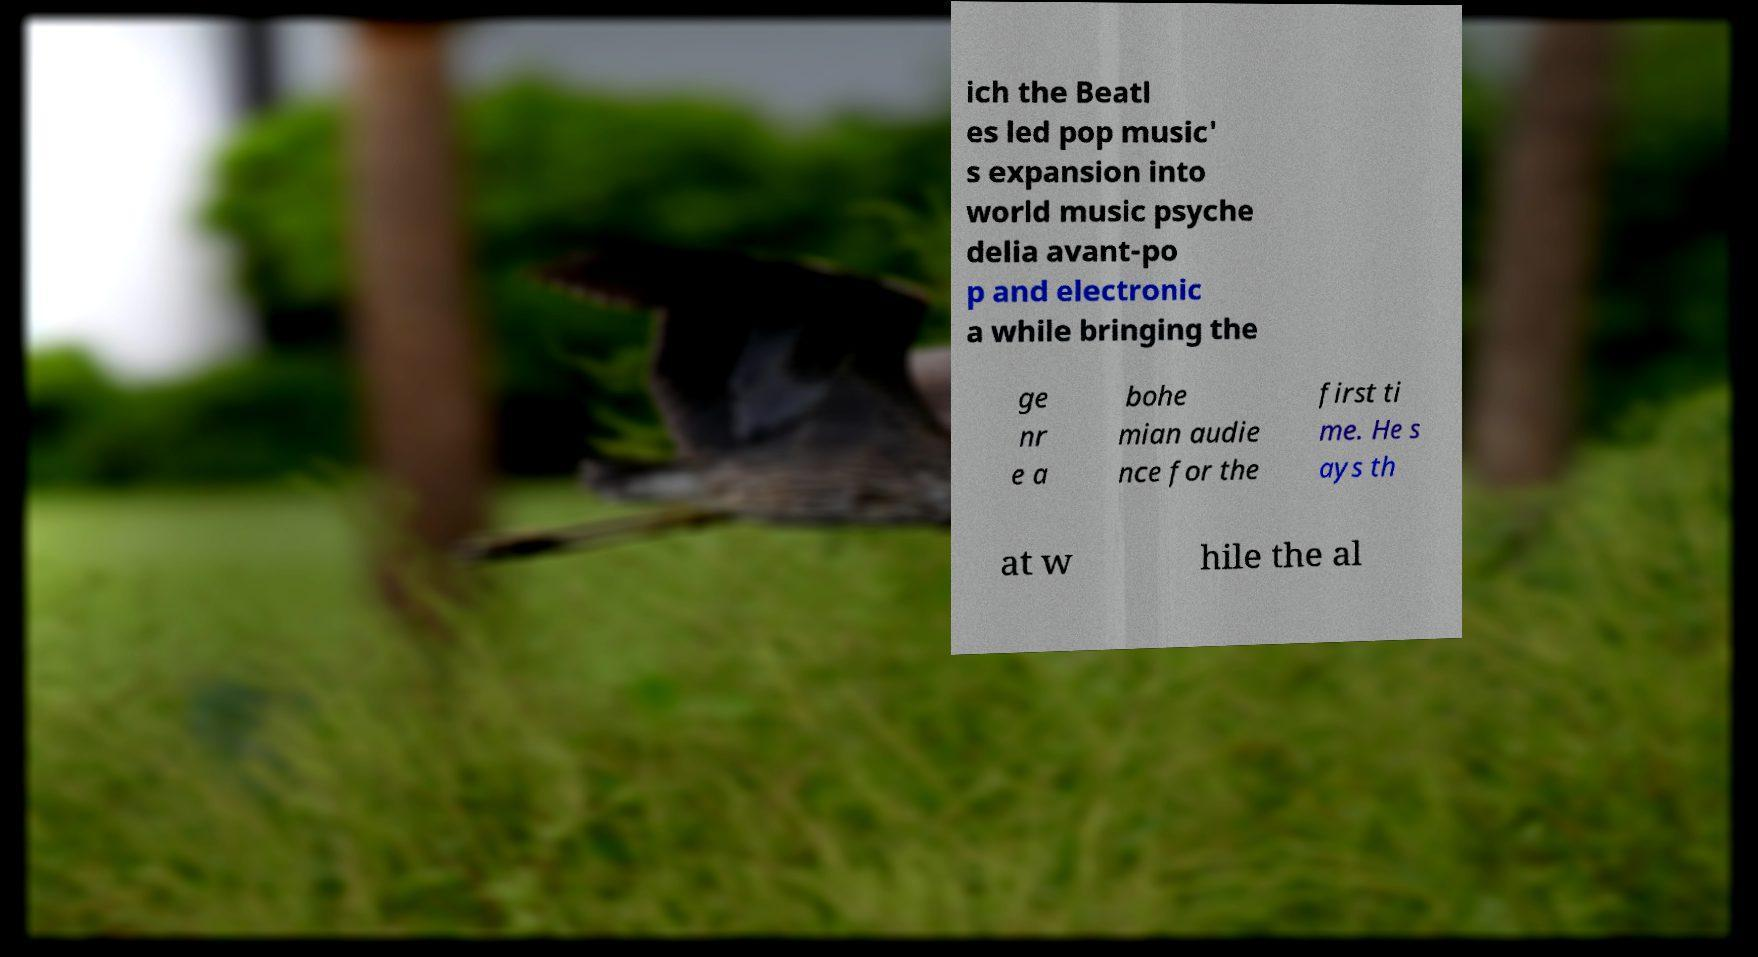Please read and relay the text visible in this image. What does it say? ich the Beatl es led pop music' s expansion into world music psyche delia avant-po p and electronic a while bringing the ge nr e a bohe mian audie nce for the first ti me. He s ays th at w hile the al 